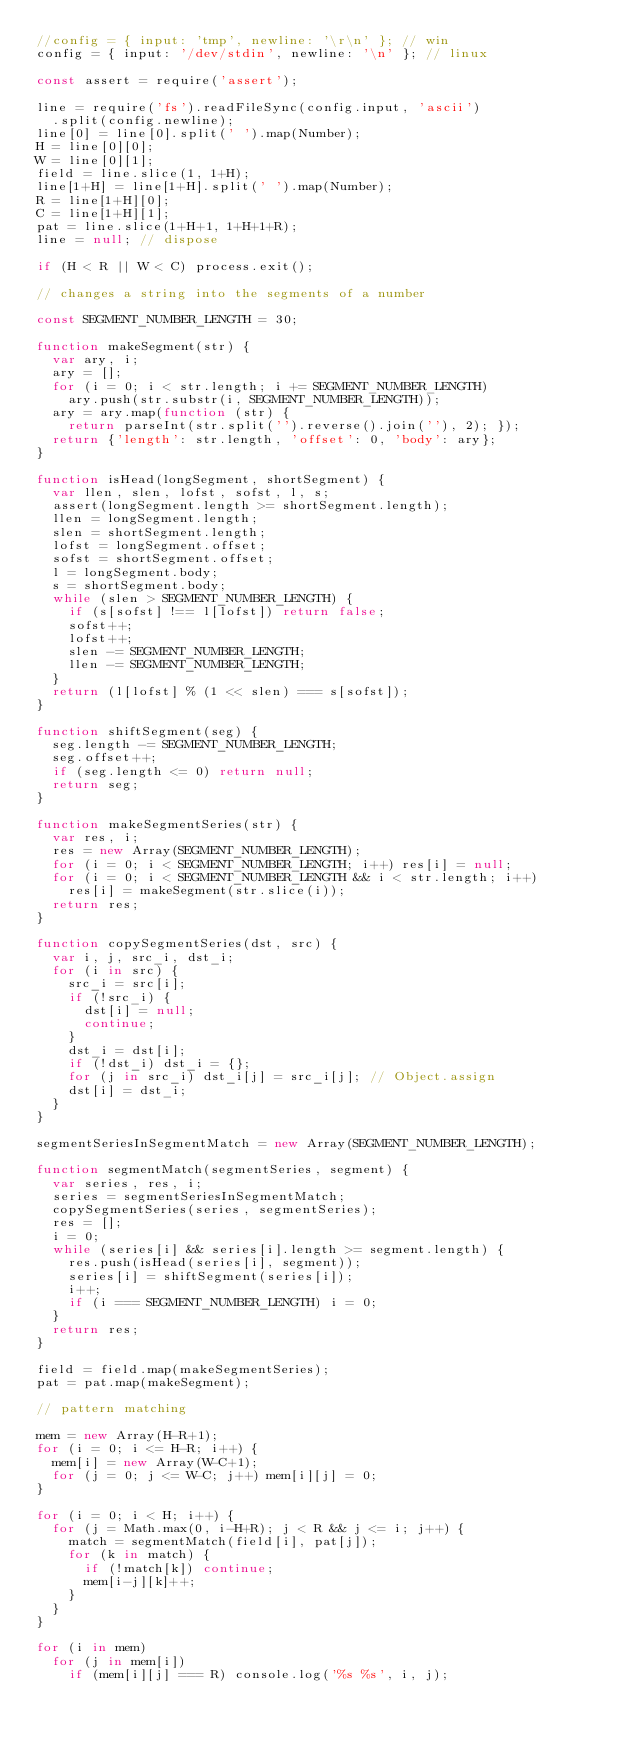Convert code to text. <code><loc_0><loc_0><loc_500><loc_500><_JavaScript_>//config = { input: 'tmp', newline: '\r\n' }; // win
config = { input: '/dev/stdin', newline: '\n' }; // linux

const assert = require('assert');

line = require('fs').readFileSync(config.input, 'ascii')
  .split(config.newline);
line[0] = line[0].split(' ').map(Number);
H = line[0][0];
W = line[0][1];
field = line.slice(1, 1+H);
line[1+H] = line[1+H].split(' ').map(Number);
R = line[1+H][0];
C = line[1+H][1];
pat = line.slice(1+H+1, 1+H+1+R);
line = null; // dispose

if (H < R || W < C) process.exit();

// changes a string into the segments of a number

const SEGMENT_NUMBER_LENGTH = 30;

function makeSegment(str) {
  var ary, i;
  ary = [];
  for (i = 0; i < str.length; i += SEGMENT_NUMBER_LENGTH)
    ary.push(str.substr(i, SEGMENT_NUMBER_LENGTH));
  ary = ary.map(function (str) {
    return parseInt(str.split('').reverse().join(''), 2); });
  return {'length': str.length, 'offset': 0, 'body': ary};
}

function isHead(longSegment, shortSegment) {
  var llen, slen, lofst, sofst, l, s;
  assert(longSegment.length >= shortSegment.length);
  llen = longSegment.length;
  slen = shortSegment.length;
  lofst = longSegment.offset;
  sofst = shortSegment.offset;
  l = longSegment.body;
  s = shortSegment.body;
  while (slen > SEGMENT_NUMBER_LENGTH) {
    if (s[sofst] !== l[lofst]) return false;
    sofst++;
    lofst++;
    slen -= SEGMENT_NUMBER_LENGTH;
    llen -= SEGMENT_NUMBER_LENGTH;
  }
  return (l[lofst] % (1 << slen) === s[sofst]);
}

function shiftSegment(seg) {
  seg.length -= SEGMENT_NUMBER_LENGTH;
  seg.offset++;
  if (seg.length <= 0) return null;
  return seg;
}

function makeSegmentSeries(str) {
  var res, i;
  res = new Array(SEGMENT_NUMBER_LENGTH);
  for (i = 0; i < SEGMENT_NUMBER_LENGTH; i++) res[i] = null;
  for (i = 0; i < SEGMENT_NUMBER_LENGTH && i < str.length; i++)
    res[i] = makeSegment(str.slice(i));
  return res;
}

function copySegmentSeries(dst, src) {
  var i, j, src_i, dst_i;
  for (i in src) {
    src_i = src[i];
    if (!src_i) {
      dst[i] = null;
      continue;
    }
    dst_i = dst[i];
    if (!dst_i) dst_i = {};
    for (j in src_i) dst_i[j] = src_i[j]; // Object.assign
    dst[i] = dst_i;
  }
}

segmentSeriesInSegmentMatch = new Array(SEGMENT_NUMBER_LENGTH);

function segmentMatch(segmentSeries, segment) {
  var series, res, i;
  series = segmentSeriesInSegmentMatch;
  copySegmentSeries(series, segmentSeries);
  res = [];
  i = 0;
  while (series[i] && series[i].length >= segment.length) {
    res.push(isHead(series[i], segment));
    series[i] = shiftSegment(series[i]);
    i++;
    if (i === SEGMENT_NUMBER_LENGTH) i = 0;
  }
  return res;
}

field = field.map(makeSegmentSeries);
pat = pat.map(makeSegment);

// pattern matching

mem = new Array(H-R+1);
for (i = 0; i <= H-R; i++) {
  mem[i] = new Array(W-C+1);
  for (j = 0; j <= W-C; j++) mem[i][j] = 0;
}

for (i = 0; i < H; i++) {
  for (j = Math.max(0, i-H+R); j < R && j <= i; j++) {
    match = segmentMatch(field[i], pat[j]);
    for (k in match) {
      if (!match[k]) continue;
      mem[i-j][k]++;
    }
  }
}

for (i in mem)
  for (j in mem[i])
    if (mem[i][j] === R) console.log('%s %s', i, j);</code> 